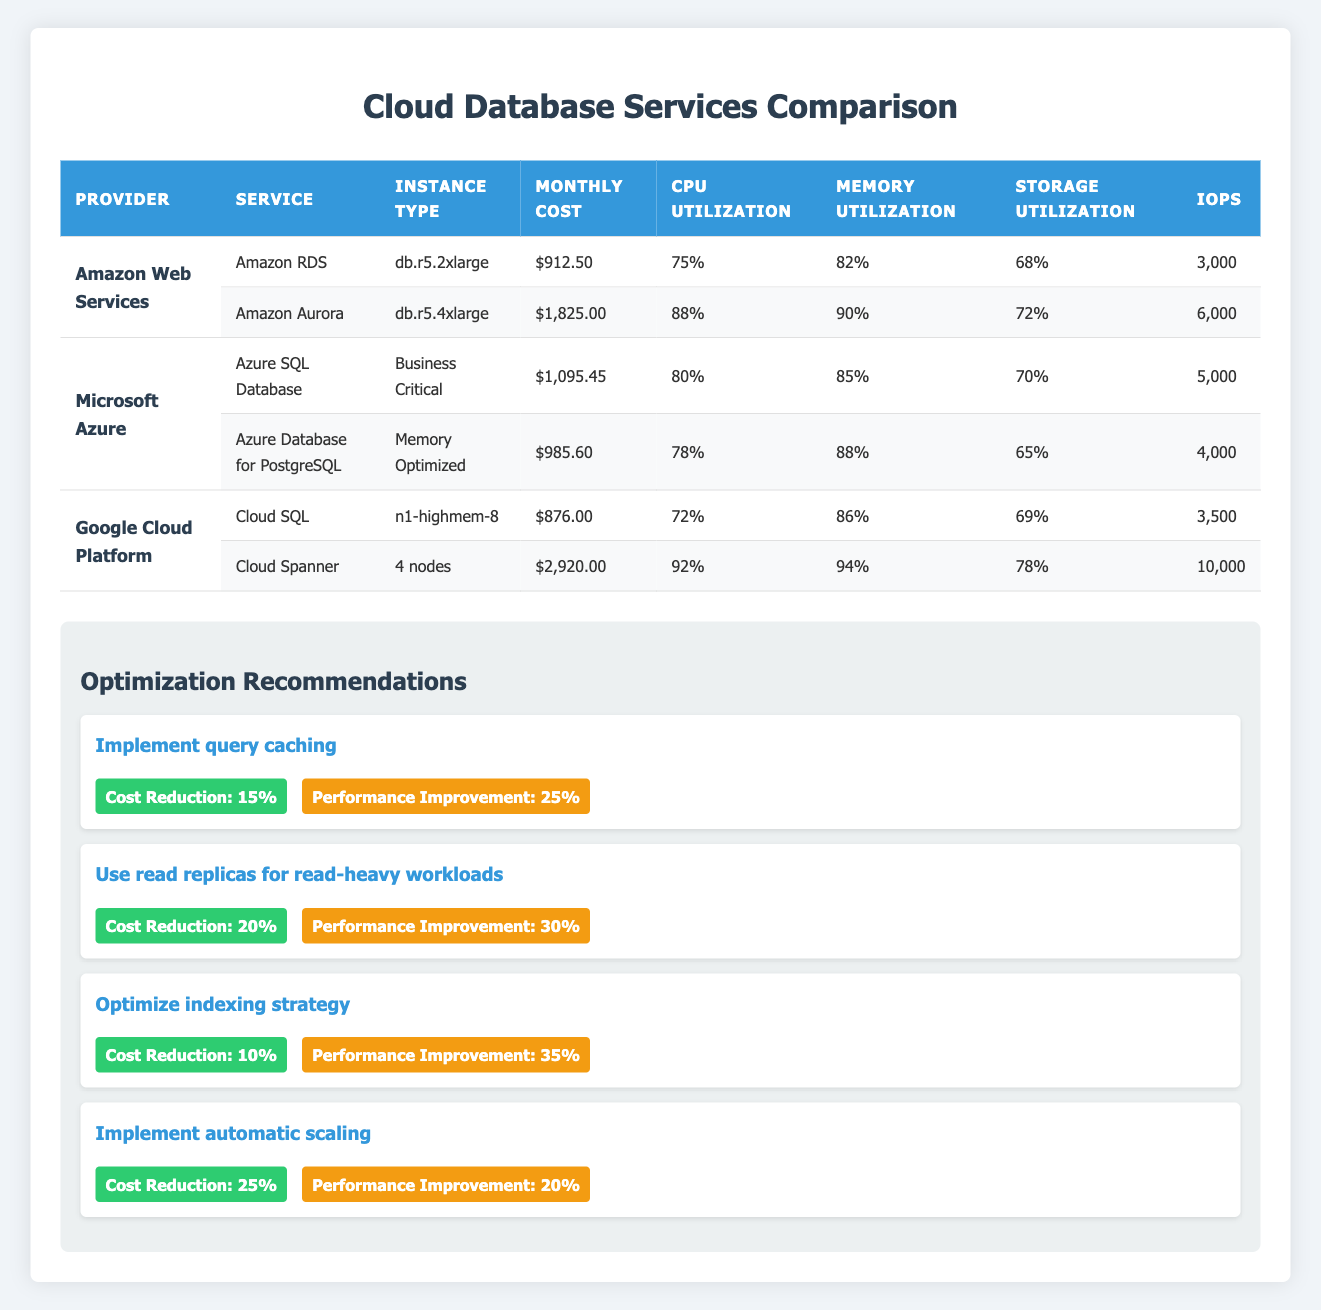What is the monthly cost of Amazon RDS? The table lists the monthly cost for Amazon RDS in the row corresponding to Amazon Web Services. It shows a monthly cost of $912.50.
Answer: $912.50 Which cloud provider offers the highest monthly cost for a single service? By reviewing the monthly costs for each service listed, Amazon Aurora ($1825.00) and Cloud Spanner ($2920.00) are the highest. Since Cloud Spanner is the highest at $2920.00, it is the answer.
Answer: Google Cloud Platform What is the combined monthly cost of all services offered by Microsoft Azure? The costs of the two services under Microsoft Azure are $1095.45 (Azure SQL Database) and $985.60 (Azure Database for PostgreSQL). Adding these gives $1095.45 + $985.60 = $2081.05.
Answer: $2081.05 Which service has the highest CPU utilization, and what is that value? By comparing the CPU utilization values across all services, the highest value is from Cloud Spanner at 92%.
Answer: 92% Is the IOPS of Amazon RDS higher than that of Cloud SQL? Amazon RDS has an IOPS of 3000, while Cloud SQL has an IOPS of 3500. Since 3000 is less than 3500, the answer is no.
Answer: No What is the average memory utilization of all the services listed? To calculate the average, first sum the memory utilization percentages: 82 + 90 + 85 + 88 + 86 + 94 = 525%. Then divide by the number of services (6) to get an average of 525 / 6 = 87.5%.
Answer: 87.5% If query caching is implemented, what is the estimated new monthly cost for Amazon Aurora? The current monthly cost for Amazon Aurora is $1825.00. With an estimated cost reduction of 15%, the cost reduction amount is $1825.00 * 0.15 = $273.75. Subtracting this from the original cost gives $1825.00 - $273.75 = $1551.25.
Answer: $1551.25 Which service has the lowest storage utilization, and what is that value? Looking through the storage utilization column, Azure Database for PostgreSQL has the lowest utilization at 65%.
Answer: 65% 